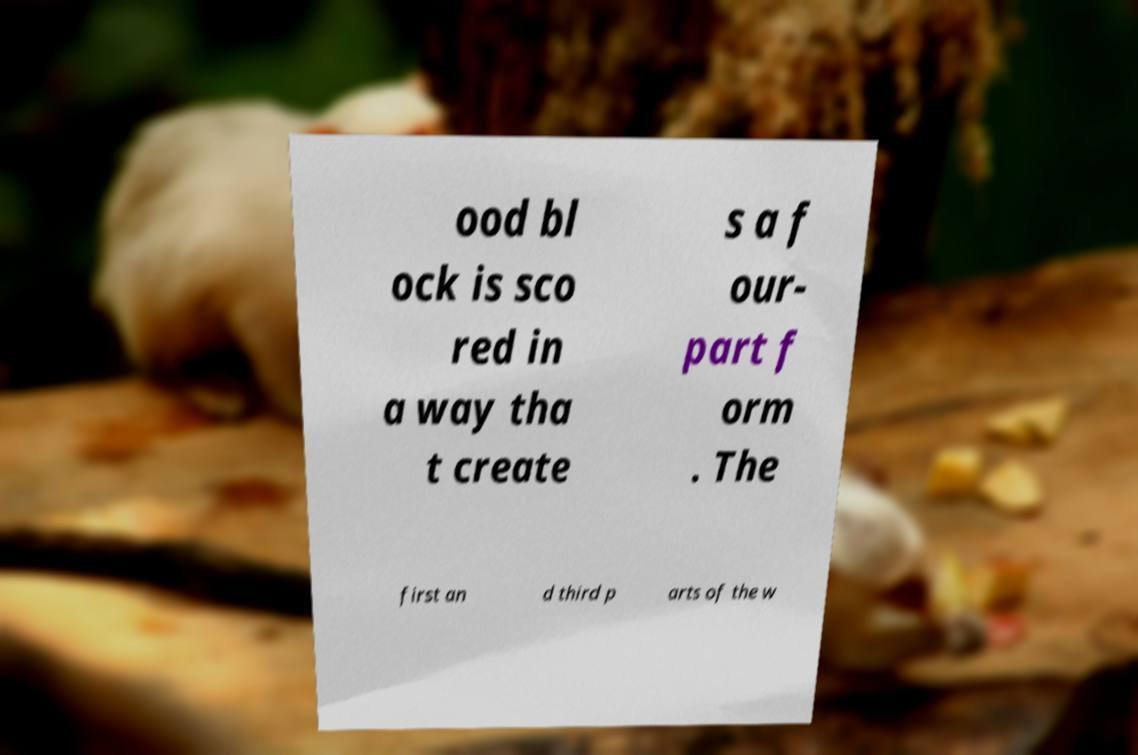Can you read and provide the text displayed in the image?This photo seems to have some interesting text. Can you extract and type it out for me? ood bl ock is sco red in a way tha t create s a f our- part f orm . The first an d third p arts of the w 